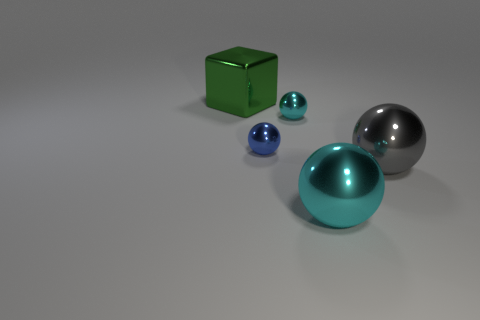There is a cyan thing behind the big cyan object; is its shape the same as the gray metal thing?
Keep it short and to the point. Yes. What number of red metallic objects are the same size as the gray metallic sphere?
Offer a terse response. 0. There is a cyan metallic ball in front of the small cyan metallic ball; is there a small blue metallic ball that is in front of it?
Provide a short and direct response. No. What number of things are cyan metallic objects that are behind the big gray metallic ball or large metallic things?
Your answer should be very brief. 4. What number of tiny metallic spheres are there?
Offer a terse response. 2. The green object that is the same material as the large gray object is what shape?
Your answer should be compact. Cube. There is a cyan metallic thing that is in front of the tiny metallic thing left of the tiny cyan metal sphere; how big is it?
Offer a very short reply. Large. What number of things are large shiny objects behind the big gray metal thing or things right of the large cube?
Make the answer very short. 5. Are there fewer large gray metal spheres than tiny red shiny balls?
Offer a terse response. No. How many objects are tiny blue spheres or cyan matte objects?
Your response must be concise. 1. 